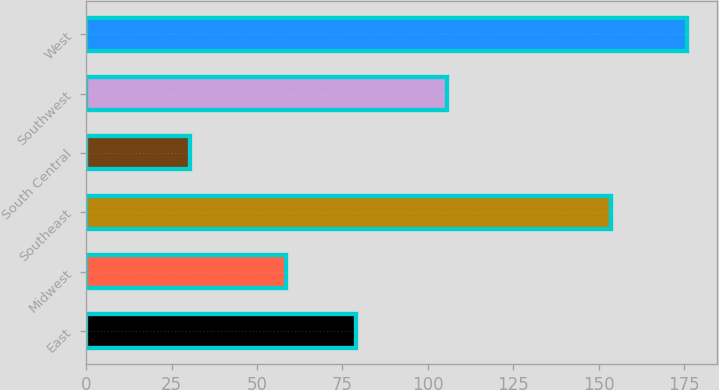Convert chart. <chart><loc_0><loc_0><loc_500><loc_500><bar_chart><fcel>East<fcel>Midwest<fcel>Southeast<fcel>South Central<fcel>Southwest<fcel>West<nl><fcel>79<fcel>58.4<fcel>153.7<fcel>30.5<fcel>105.7<fcel>175.8<nl></chart> 